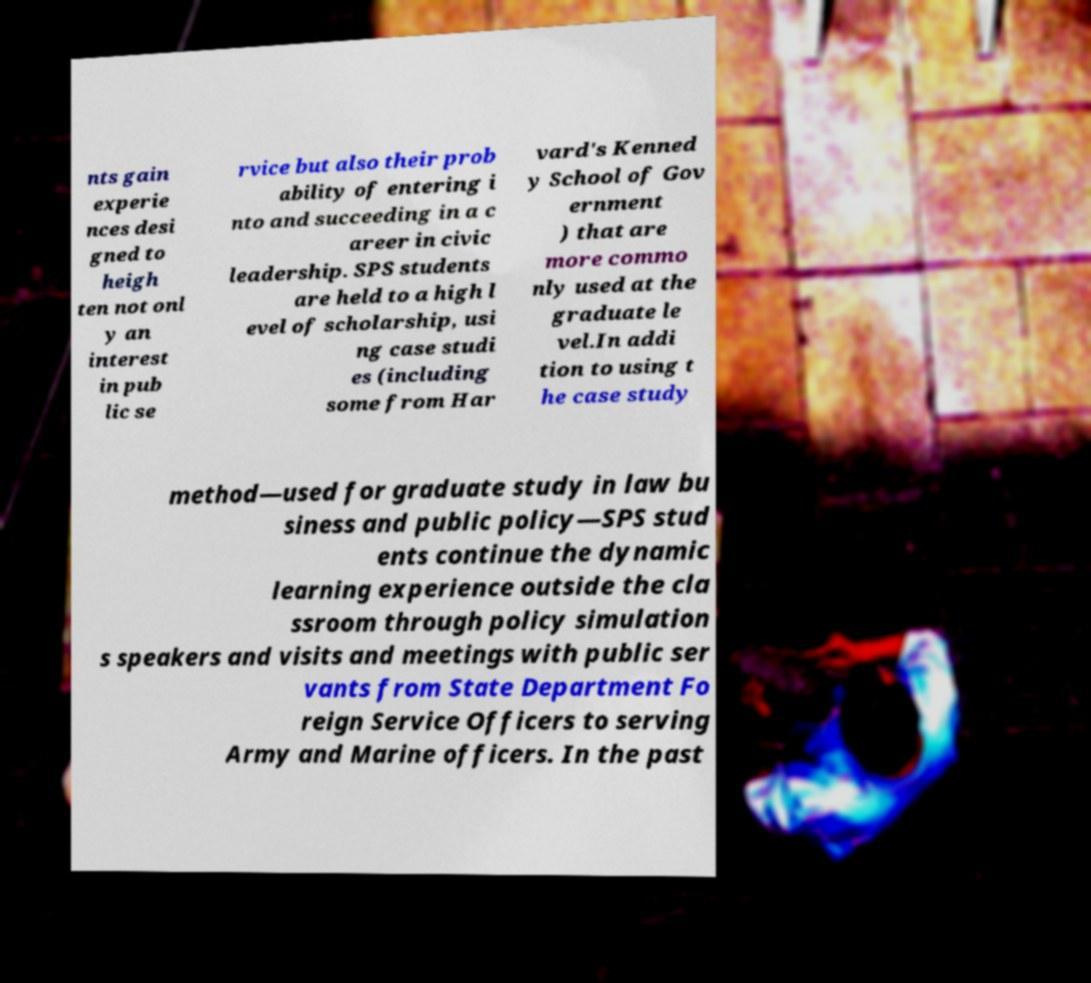What messages or text are displayed in this image? I need them in a readable, typed format. nts gain experie nces desi gned to heigh ten not onl y an interest in pub lic se rvice but also their prob ability of entering i nto and succeeding in a c areer in civic leadership. SPS students are held to a high l evel of scholarship, usi ng case studi es (including some from Har vard's Kenned y School of Gov ernment ) that are more commo nly used at the graduate le vel.In addi tion to using t he case study method—used for graduate study in law bu siness and public policy—SPS stud ents continue the dynamic learning experience outside the cla ssroom through policy simulation s speakers and visits and meetings with public ser vants from State Department Fo reign Service Officers to serving Army and Marine officers. In the past 